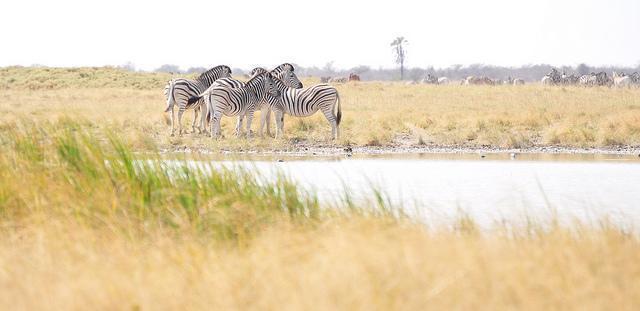How many zebras are drinking?
Give a very brief answer. 0. How many zebras are there?
Give a very brief answer. 2. 